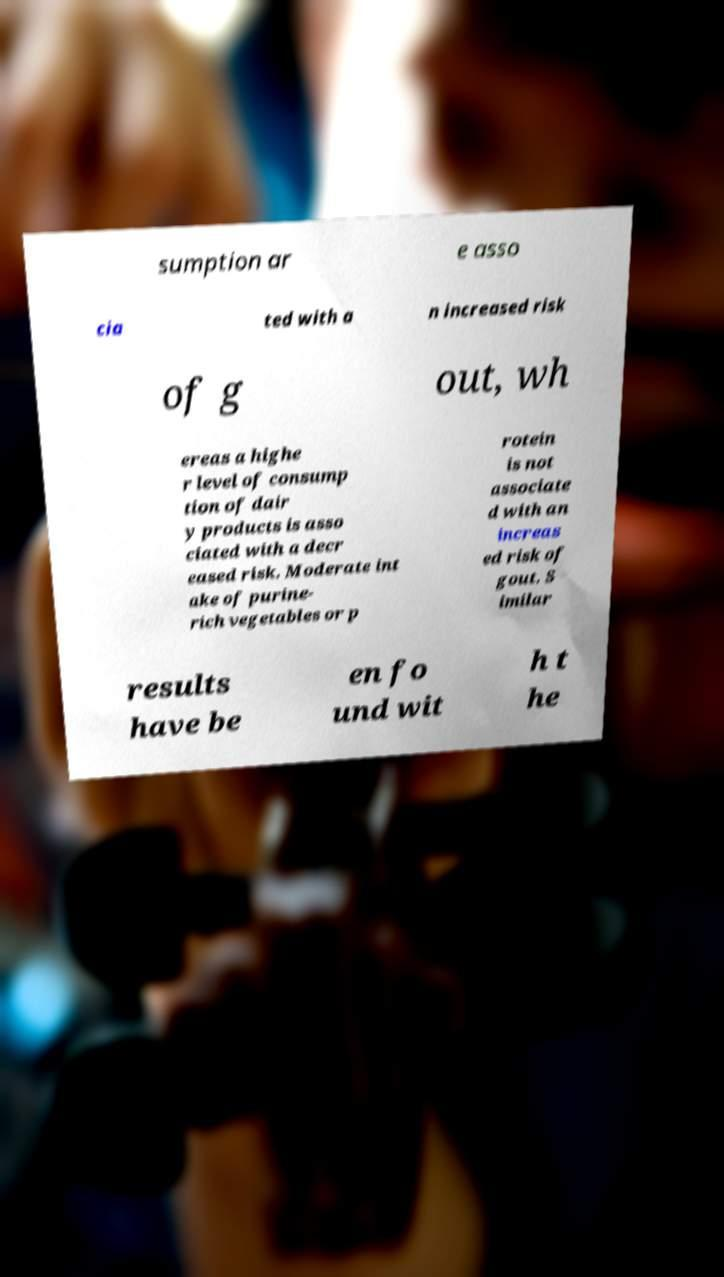Please read and relay the text visible in this image. What does it say? sumption ar e asso cia ted with a n increased risk of g out, wh ereas a highe r level of consump tion of dair y products is asso ciated with a decr eased risk. Moderate int ake of purine- rich vegetables or p rotein is not associate d with an increas ed risk of gout. S imilar results have be en fo und wit h t he 